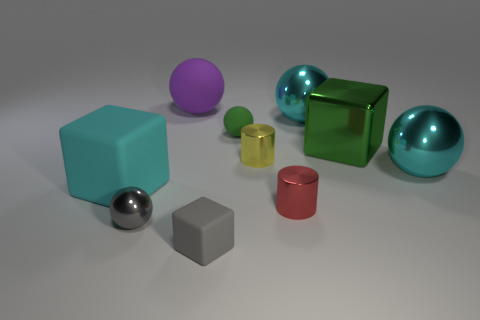Subtract all red spheres. Subtract all yellow blocks. How many spheres are left? 5 Subtract all cubes. How many objects are left? 7 Add 9 red metallic things. How many red metallic things exist? 10 Subtract 1 green blocks. How many objects are left? 9 Subtract all red metal cubes. Subtract all tiny gray metallic things. How many objects are left? 9 Add 3 tiny gray rubber blocks. How many tiny gray rubber blocks are left? 4 